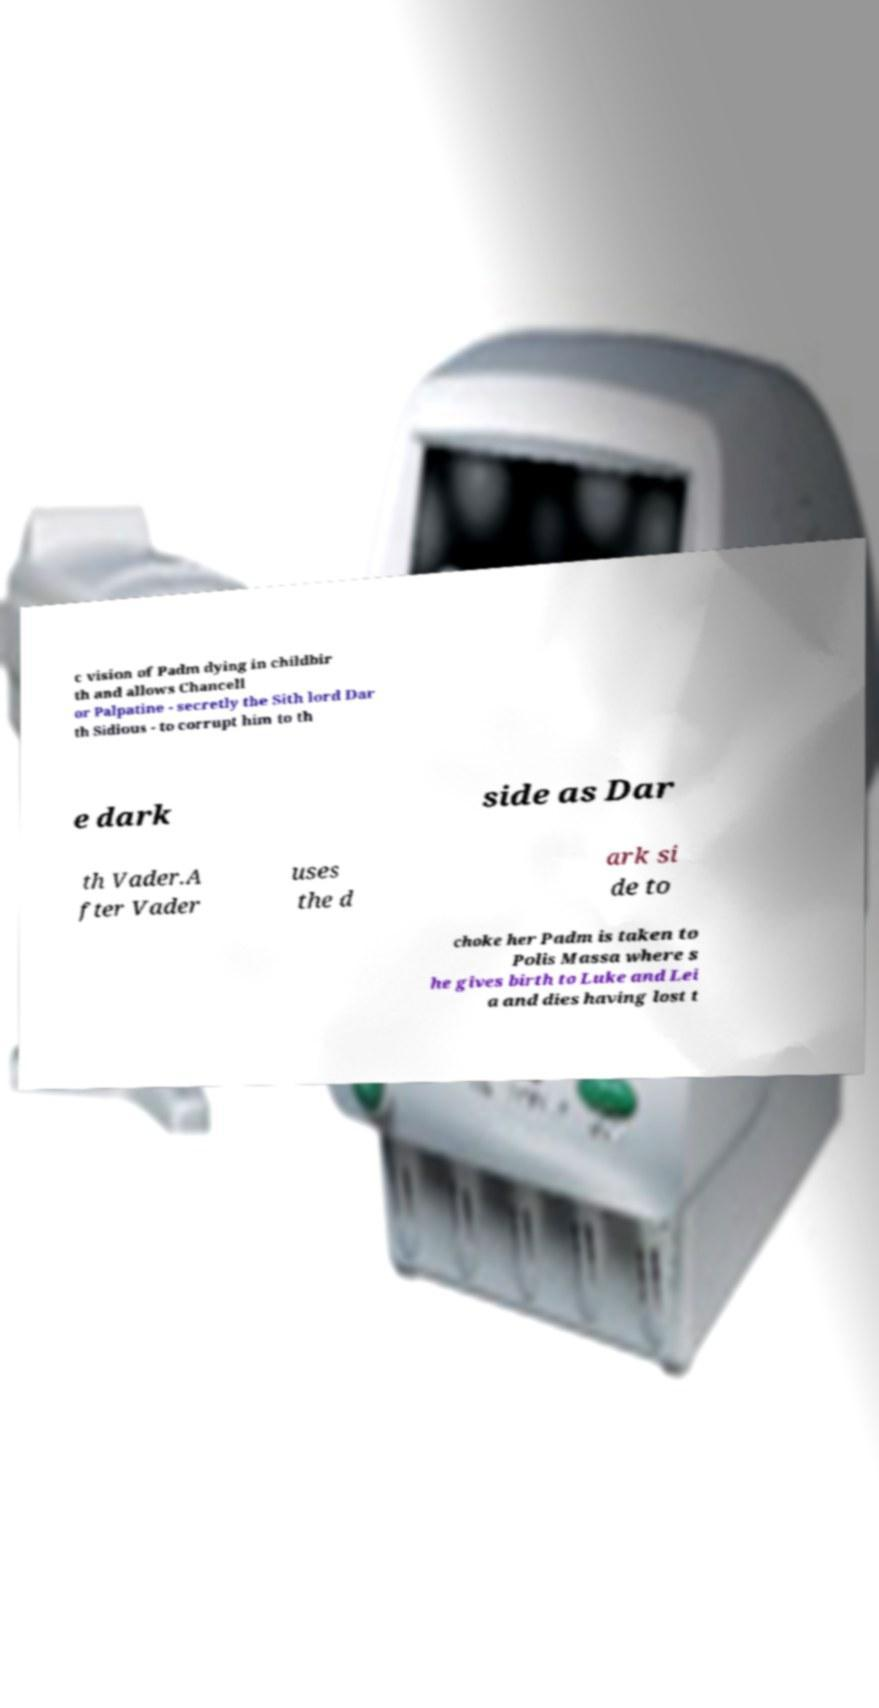Can you read and provide the text displayed in the image?This photo seems to have some interesting text. Can you extract and type it out for me? c vision of Padm dying in childbir th and allows Chancell or Palpatine - secretly the Sith lord Dar th Sidious - to corrupt him to th e dark side as Dar th Vader.A fter Vader uses the d ark si de to choke her Padm is taken to Polis Massa where s he gives birth to Luke and Lei a and dies having lost t 